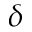<formula> <loc_0><loc_0><loc_500><loc_500>\delta</formula> 